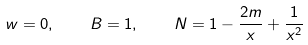<formula> <loc_0><loc_0><loc_500><loc_500>w = 0 , \quad B = 1 , \quad N = 1 - \frac { 2 m } { x } + \frac { 1 } { x ^ { 2 } }</formula> 